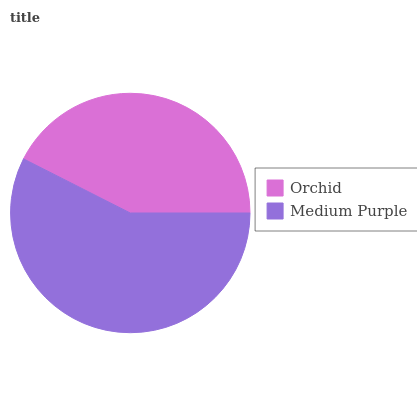Is Orchid the minimum?
Answer yes or no. Yes. Is Medium Purple the maximum?
Answer yes or no. Yes. Is Medium Purple the minimum?
Answer yes or no. No. Is Medium Purple greater than Orchid?
Answer yes or no. Yes. Is Orchid less than Medium Purple?
Answer yes or no. Yes. Is Orchid greater than Medium Purple?
Answer yes or no. No. Is Medium Purple less than Orchid?
Answer yes or no. No. Is Medium Purple the high median?
Answer yes or no. Yes. Is Orchid the low median?
Answer yes or no. Yes. Is Orchid the high median?
Answer yes or no. No. Is Medium Purple the low median?
Answer yes or no. No. 